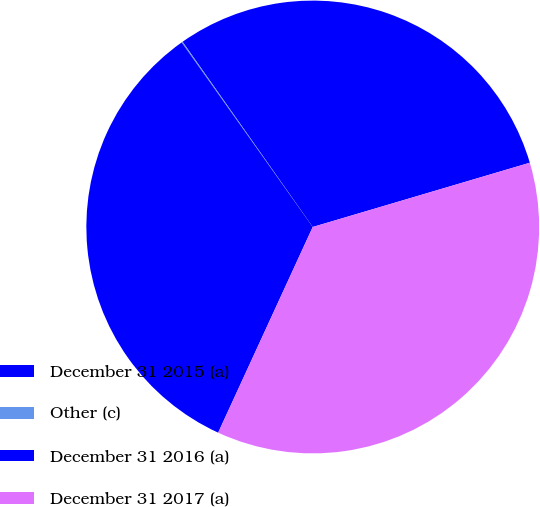Convert chart to OTSL. <chart><loc_0><loc_0><loc_500><loc_500><pie_chart><fcel>December 31 2015 (a)<fcel>Other (c)<fcel>December 31 2016 (a)<fcel>December 31 2017 (a)<nl><fcel>30.17%<fcel>0.08%<fcel>33.31%<fcel>36.44%<nl></chart> 